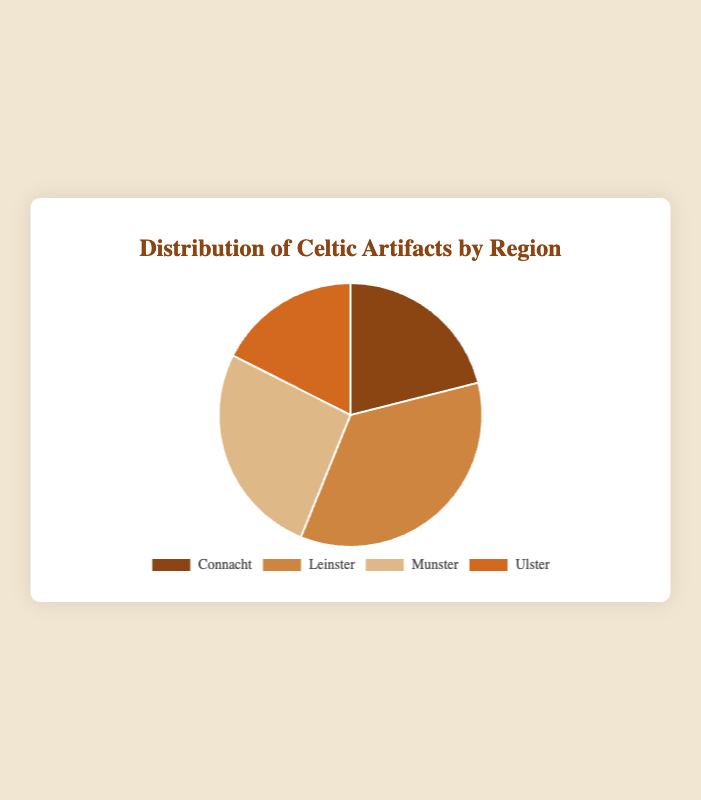What region has the highest number of Celtic artifacts? Leinster has the highest number of Celtic artifacts as indicated by the largest section of the pie chart.
Answer: Leinster What is the total number of artifacts across all regions? Sum the artifacts for each region: Connacht (120) + Leinster (200) + Munster (150) + Ulster (100) = 570.
Answer: 570 Which two regions together hold more artifacts than Leinster? Munster and Connacht together hold more artifacts than Leinster. Sum of Munster (150) and Connacht (120) is 270, which is greater than Leinster's 200.
Answer: Munster and Connacht How many artifacts are there in Munster relative to Ulster? Munster has 150 artifacts, and Ulster has 100 artifacts. 150 / 100 = 1.5, so Munster has 1.5 times the artifacts as Ulster.
Answer: 1.5 times What percentage of the total artifacts does Connacht have? Connacht has 120 artifacts out of a total of 570. (120 / 570) * 100 ≈ 21.05%.
Answer: 21.05% If you combine artifacts from Connacht and Ulster, do they outnumber those in Munster? Connacht (120) + Ulster (100) = 220, which is greater than Munster's 150.
Answer: Yes What region has the smallest number of artifacts? Ulster has the smallest number of artifacts as indicated by the smallest section of the pie chart.
Answer: Ulster How does the artifact count in Leinster compare to the combined artifact count of Connacht and Ulster? Leinster has 200 artifacts, while Connacht and Ulster together have 120 + 100 = 220, which is slightly more.
Answer: Slightly less What is the average number of artifacts per region? Sum the artifacts for each region: Connacht (120) + Leinster (200) + Munster (150) + Ulster (100) = 570. There are 4 regions, so the average is 570 / 4 = 142.5.
Answer: 142.5 Which region's artifact count is closest to the average number of artifacts per region? The average number of artifacts is 142.5. Munster has 150 artifacts, which is the closest to 142.5.
Answer: Munster 